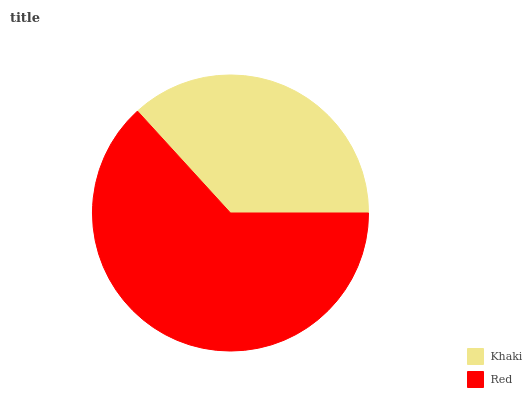Is Khaki the minimum?
Answer yes or no. Yes. Is Red the maximum?
Answer yes or no. Yes. Is Red the minimum?
Answer yes or no. No. Is Red greater than Khaki?
Answer yes or no. Yes. Is Khaki less than Red?
Answer yes or no. Yes. Is Khaki greater than Red?
Answer yes or no. No. Is Red less than Khaki?
Answer yes or no. No. Is Red the high median?
Answer yes or no. Yes. Is Khaki the low median?
Answer yes or no. Yes. Is Khaki the high median?
Answer yes or no. No. Is Red the low median?
Answer yes or no. No. 